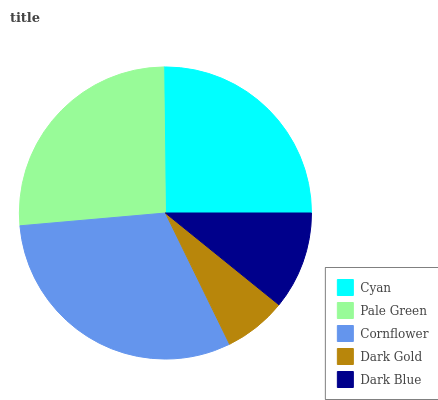Is Dark Gold the minimum?
Answer yes or no. Yes. Is Cornflower the maximum?
Answer yes or no. Yes. Is Pale Green the minimum?
Answer yes or no. No. Is Pale Green the maximum?
Answer yes or no. No. Is Pale Green greater than Cyan?
Answer yes or no. Yes. Is Cyan less than Pale Green?
Answer yes or no. Yes. Is Cyan greater than Pale Green?
Answer yes or no. No. Is Pale Green less than Cyan?
Answer yes or no. No. Is Cyan the high median?
Answer yes or no. Yes. Is Cyan the low median?
Answer yes or no. Yes. Is Cornflower the high median?
Answer yes or no. No. Is Dark Gold the low median?
Answer yes or no. No. 